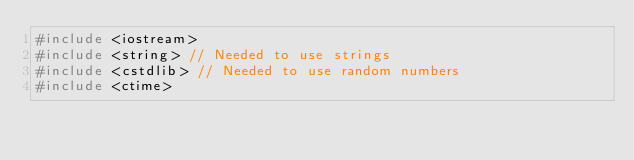<code> <loc_0><loc_0><loc_500><loc_500><_C++_>#include <iostream>
#include <string> // Needed to use strings
#include <cstdlib> // Needed to use random numbers
#include <ctime>
</code> 